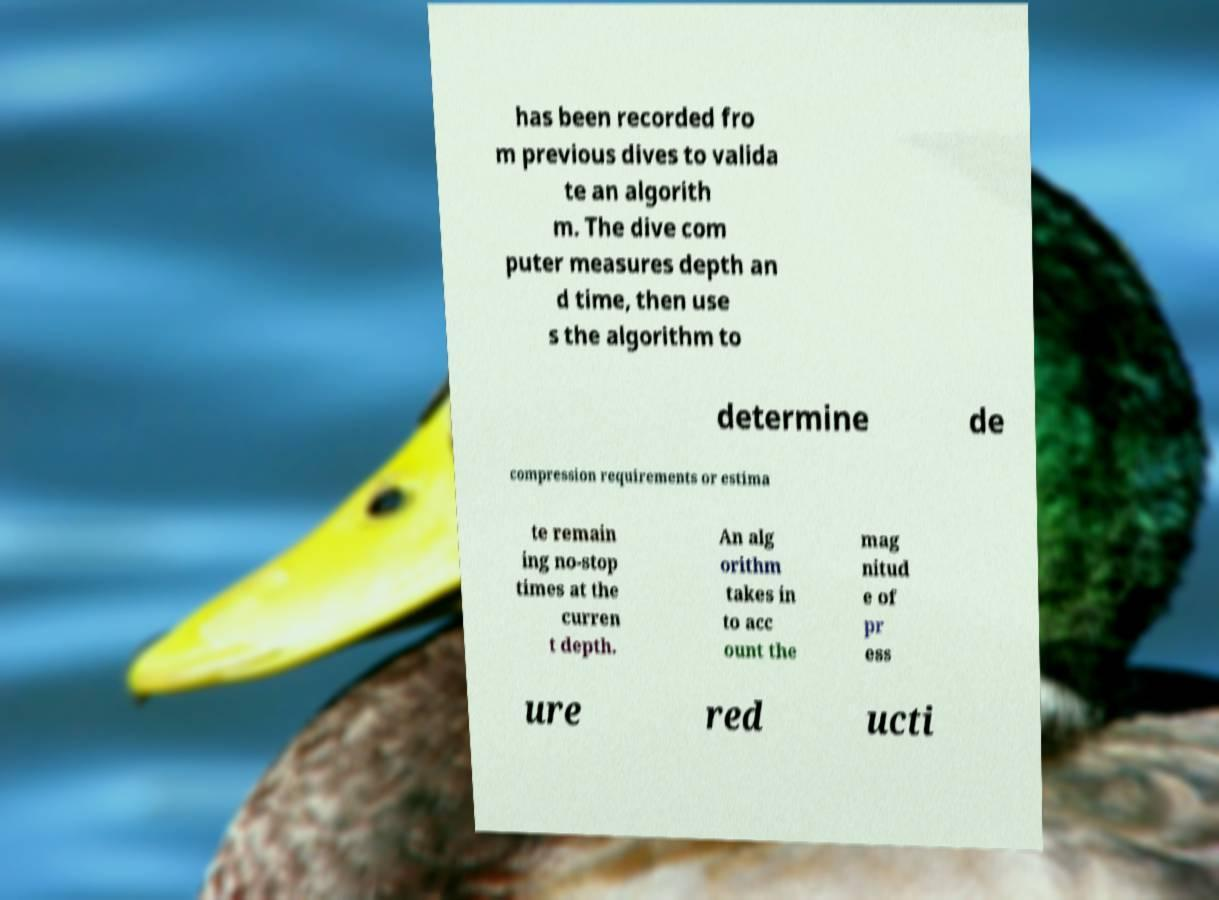Please identify and transcribe the text found in this image. has been recorded fro m previous dives to valida te an algorith m. The dive com puter measures depth an d time, then use s the algorithm to determine de compression requirements or estima te remain ing no-stop times at the curren t depth. An alg orithm takes in to acc ount the mag nitud e of pr ess ure red ucti 